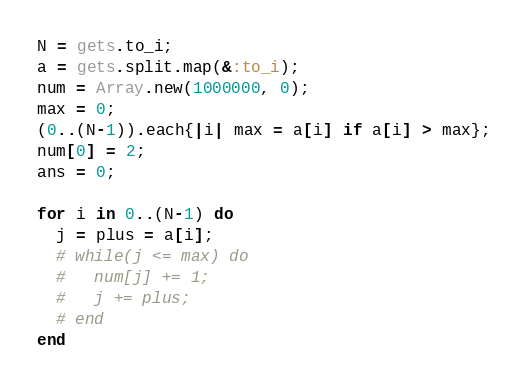<code> <loc_0><loc_0><loc_500><loc_500><_Ruby_>N = gets.to_i;
a = gets.split.map(&:to_i);
num = Array.new(1000000, 0);
max = 0;
(0..(N-1)).each{|i| max = a[i] if a[i] > max};
num[0] = 2;
ans = 0;

for i in 0..(N-1) do
  j = plus = a[i];
  # while(j <= max) do
  #   num[j] += 1;
  #   j += plus;
  # end
end
</code> 